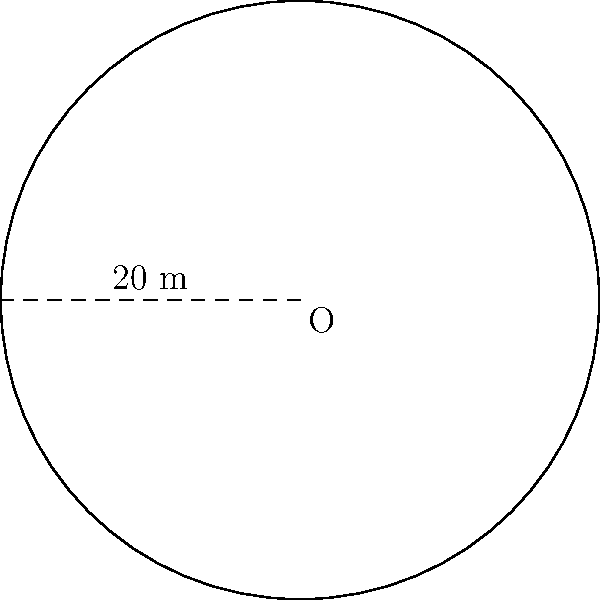During your stay at a historic college, you come across a circular courtyard. A plaque mentions that the radius of the courtyard is 20 meters. Calculate the circumference of this courtyard to the nearest meter. To find the circumference of a circular courtyard, we need to use the formula for the circumference of a circle:

$$C = 2\pi r$$

Where:
$C$ = circumference
$\pi$ = pi (approximately 3.14159)
$r$ = radius

Given:
$r = 20$ meters

Step 1: Substitute the values into the formula:
$$C = 2\pi(20)$$

Step 2: Calculate:
$$C = 2 \times 3.14159 \times 20$$
$$C = 125.6636 \text{ meters}$$

Step 3: Round to the nearest meter:
$$C \approx 126 \text{ meters}$$

Therefore, the circumference of the circular courtyard is approximately 126 meters.
Answer: 126 meters 